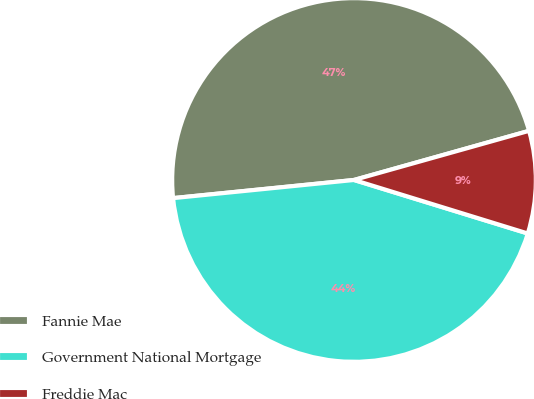Convert chart. <chart><loc_0><loc_0><loc_500><loc_500><pie_chart><fcel>Fannie Mae<fcel>Government National Mortgage<fcel>Freddie Mac<nl><fcel>47.23%<fcel>43.65%<fcel>9.11%<nl></chart> 